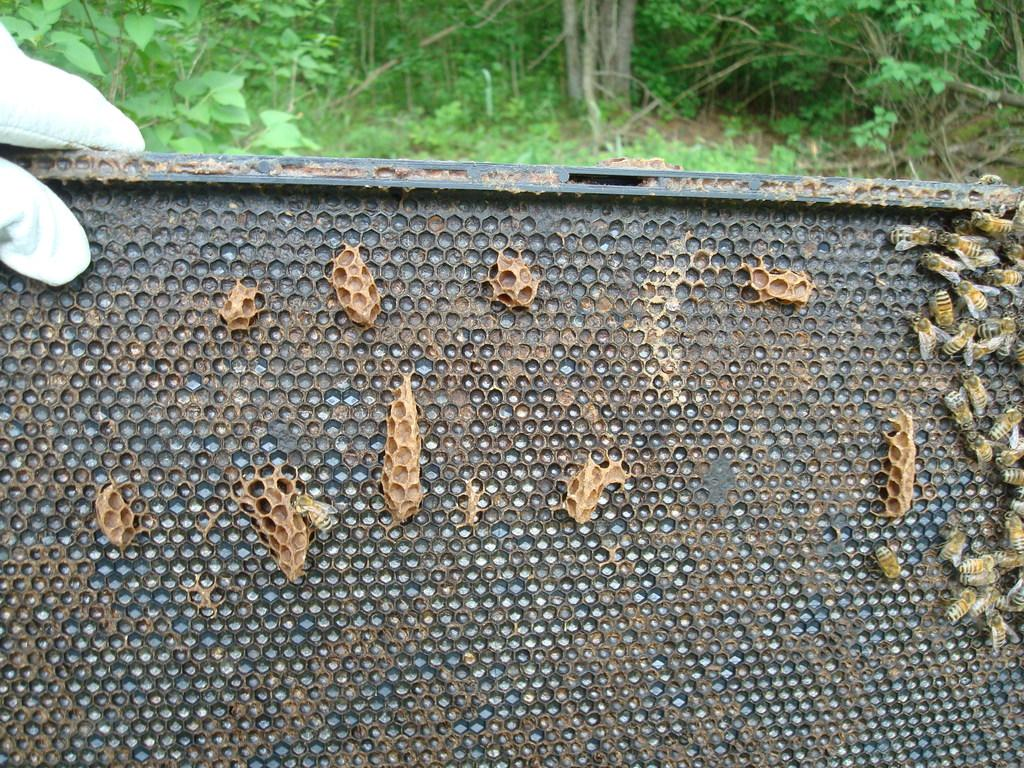What is the main object in the image? There is a black color board in the image. What is on the color board? There are insects on the board. What colors are the insects? The insects are in brown, yellow, and white colors. Whose hand is on the board? A person's hand is on the board. What can be seen in the background of the image? There are trees visible on the back side of the image. What type of agreement is being discussed in the image? There is no discussion or agreement present in the image; it features a black color board with insects and a person's hand. What season is depicted in the image? The image does not depict a specific season; it only shows a black color board with insects, a person's hand, and trees in the background. 